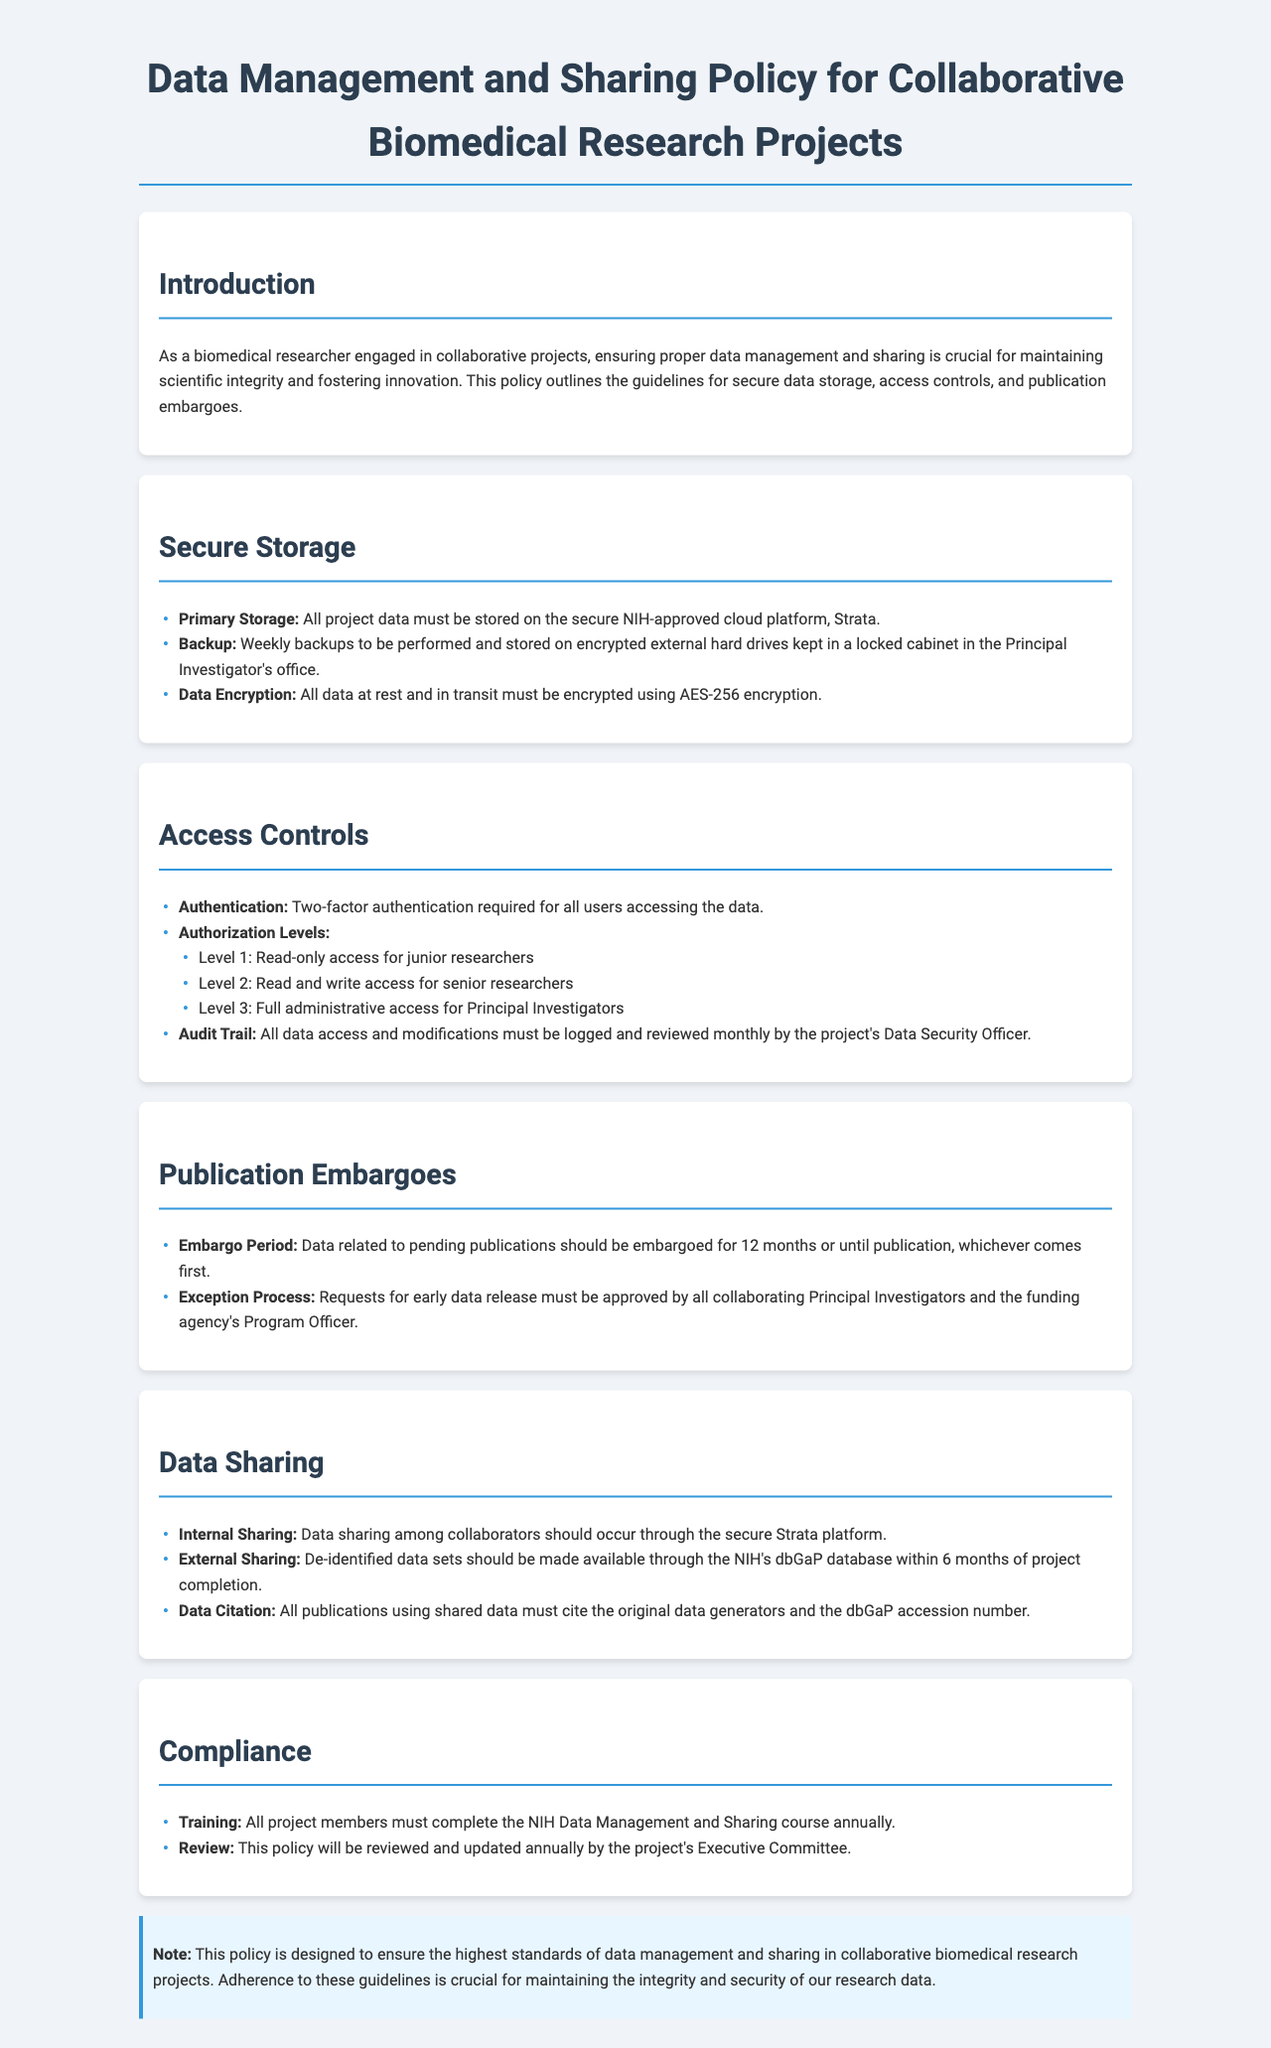What is the primary storage platform for project data? The document specifies that all project data must be stored on a secure NIH-approved cloud platform, Strata.
Answer: Strata What encryption standard must be used for data? The policy states that all data at rest and in transit must be encrypted using AES-256 encryption.
Answer: AES-256 What level of access do junior researchers have? The document outlines that junior researchers have read-only access, which is labeled as Level 1.
Answer: Read-only access How often must the audit trail be reviewed? The policy requires that all data access and modifications must be logged and reviewed monthly by the project's Data Security Officer.
Answer: Monthly What is the embargo period for data related to pending publications? The document indicates that data related to pending publications should be embargoed for 12 months or until publication, whichever comes first.
Answer: 12 months What is required for internal sharing of data among collaborators? The document specifies that data sharing among collaborators should occur through the secure Strata platform.
Answer: Secure Strata platform How frequently will this policy be reviewed? The policy states that this policy will be reviewed and updated annually by the project's Executive Committee.
Answer: Annually What is required for project members annually? The document mandates that all project members must complete the NIH Data Management and Sharing course annually.
Answer: NIH Data Management and Sharing course What must be done with de-identified data sets after project completion? The policy states that de-identified data sets should be made available through the NIH's dbGaP database within 6 months of project completion.
Answer: 6 months 